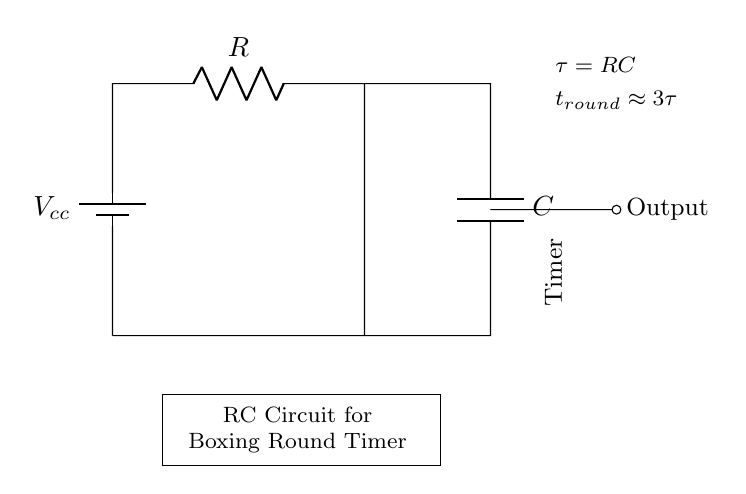What components are present in this circuit? The circuit contains a resistor, a capacitor, and a battery. These components are indicated by the symbols in the diagram.
Answer: Resistor, Capacitor, Battery What does the symbol "C" represent in the circuit? The symbol "C" represents the capacitor in the circuit, used for storing charge. It is labeled clearly next to its corresponding symbol.
Answer: Capacitor What is the formula for the time constant in this RC circuit? The time constant (tau) is represented in the diagram as the product of the resistance (R) and the capacitance (C). This is a key relationship in RC circuits.
Answer: tau = RC What is the approximate time for one boxing round according to the diagram? The diagram specifies that the approximate time for one boxing round is three times the time constant, which is expressed as t_round approximately equal to three times tau.
Answer: 3 tau How does increasing the resistance (R) affect the timing of the rounds? Increasing the resistance (R) will increase the time constant tau, which in turn results in a longer duration for each round based on the relationship t_round approximately equal to three times tau.
Answer: Longer rounds What is the role of the battery in this circuit? The battery provides the voltage needed to charge the capacitor, enabling the timing function of the circuit as it discharges through the resistor.
Answer: Voltage supply 